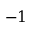Convert formula to latex. <formula><loc_0><loc_0><loc_500><loc_500>- 1</formula> 